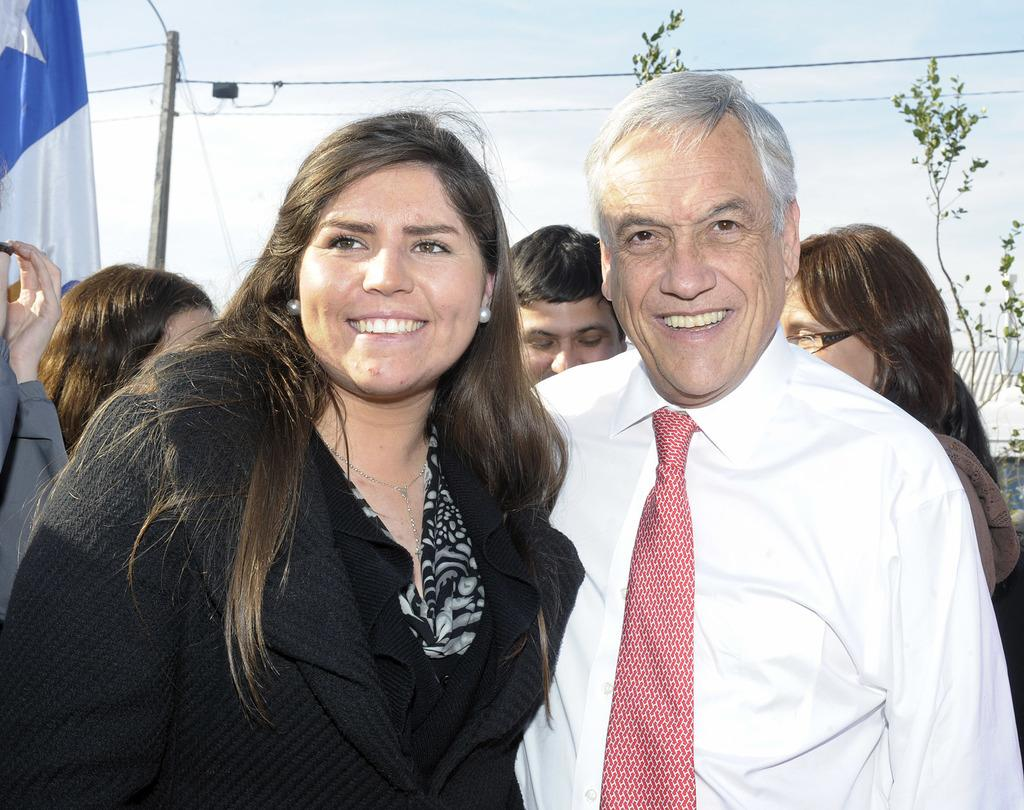Who or what can be seen in the image? There are people in the image. What else is present in the image besides people? There are plants, poles, wires, and objects on the left side of the image. Can you describe the plants in the image? The plants are not described in the provided facts, so we cannot provide a specific answer. What is visible in the background of the image? The sky is visible in the image. What type of orange is being picked by the farmer in the image? There is no farmer or orange present in the image. What kind of guide is leading the group of people in the image? There is no guide or group of people present in the image. 